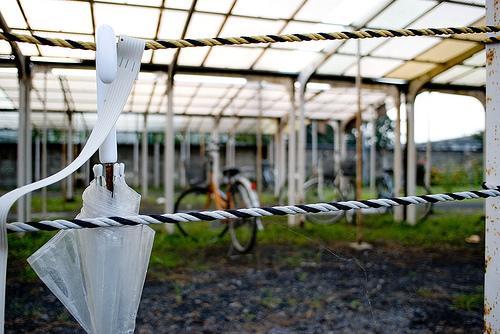What is written on the umbrella?
Short answer required. Nothing. What form of transportation is in the background?
Write a very short answer. Bike. Is the owner of the umbrella a man?
Concise answer only. No. Is there an umbrella in this image?
Keep it brief. Yes. 